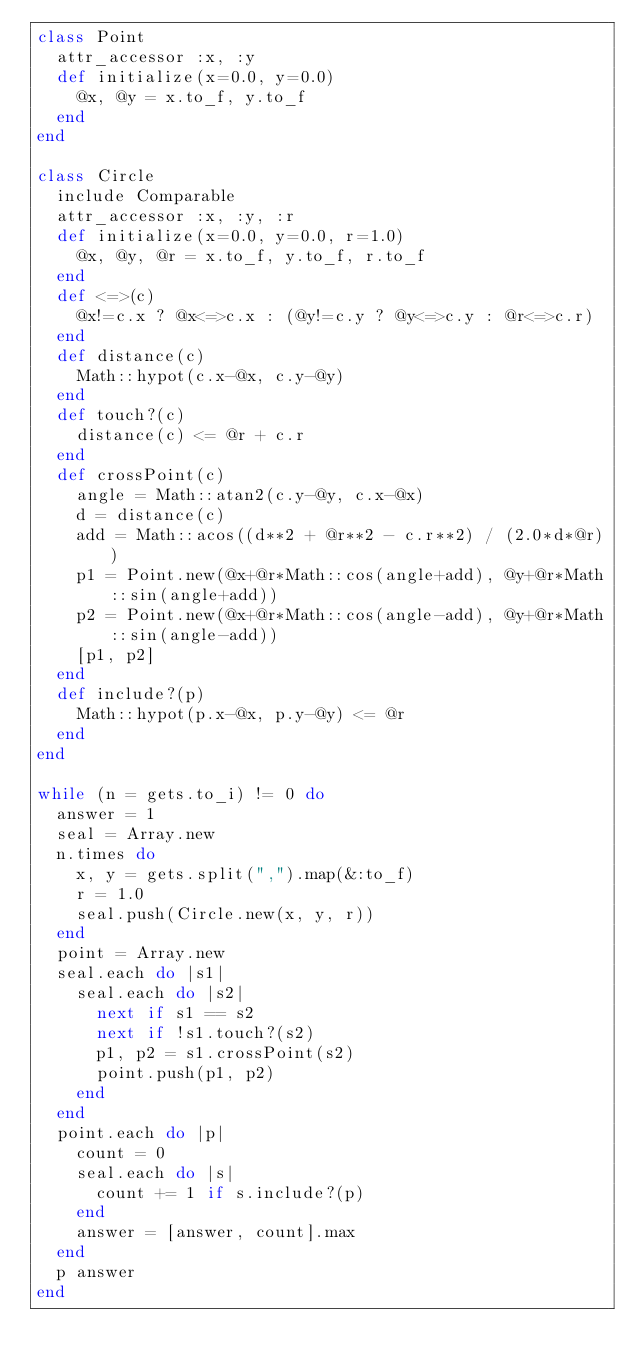Convert code to text. <code><loc_0><loc_0><loc_500><loc_500><_Ruby_>class Point
  attr_accessor :x, :y
  def initialize(x=0.0, y=0.0)
    @x, @y = x.to_f, y.to_f
  end
end

class Circle
  include Comparable
  attr_accessor :x, :y, :r
  def initialize(x=0.0, y=0.0, r=1.0)
    @x, @y, @r = x.to_f, y.to_f, r.to_f
  end
  def <=>(c)
    @x!=c.x ? @x<=>c.x : (@y!=c.y ? @y<=>c.y : @r<=>c.r)
  end
  def distance(c)
    Math::hypot(c.x-@x, c.y-@y)
  end
  def touch?(c)
    distance(c) <= @r + c.r
  end
  def crossPoint(c)
    angle = Math::atan2(c.y-@y, c.x-@x)
    d = distance(c)
    add = Math::acos((d**2 + @r**2 - c.r**2) / (2.0*d*@r))
    p1 = Point.new(@x+@r*Math::cos(angle+add), @y+@r*Math::sin(angle+add))
    p2 = Point.new(@x+@r*Math::cos(angle-add), @y+@r*Math::sin(angle-add))
    [p1, p2]
  end
  def include?(p)
    Math::hypot(p.x-@x, p.y-@y) <= @r
  end
end

while (n = gets.to_i) != 0 do
  answer = 1
  seal = Array.new
  n.times do
    x, y = gets.split(",").map(&:to_f)
    r = 1.0
    seal.push(Circle.new(x, y, r))
  end
  point = Array.new
  seal.each do |s1|
    seal.each do |s2|
      next if s1 == s2
      next if !s1.touch?(s2)
      p1, p2 = s1.crossPoint(s2)
      point.push(p1, p2)
    end
  end
  point.each do |p|
    count = 0
    seal.each do |s|
      count += 1 if s.include?(p)
    end
    answer = [answer, count].max
  end
  p answer
end</code> 